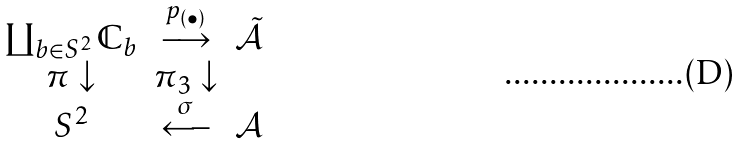Convert formula to latex. <formula><loc_0><loc_0><loc_500><loc_500>\begin{matrix} \coprod _ { b { \in } S ^ { 2 } } { \mathbb { C } } _ { b } & \overset { p _ { ( \bullet ) } } { \longrightarrow } & \tilde { \mathcal { A } } \\ \pi \downarrow & \pi _ { 3 } \downarrow \\ { S ^ { 2 } } & \overset { \sigma } { \longleftarrow } & { \mathcal { A } } \\ \end{matrix}</formula> 